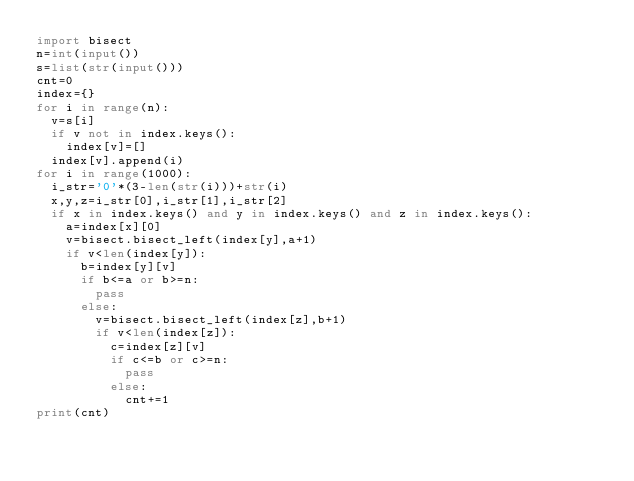Convert code to text. <code><loc_0><loc_0><loc_500><loc_500><_Python_>import bisect
n=int(input())
s=list(str(input()))
cnt=0
index={}
for i in range(n):
  v=s[i]
  if v not in index.keys():
    index[v]=[]
  index[v].append(i)
for i in range(1000):
  i_str='0'*(3-len(str(i)))+str(i)
  x,y,z=i_str[0],i_str[1],i_str[2]
  if x in index.keys() and y in index.keys() and z in index.keys():
    a=index[x][0]
    v=bisect.bisect_left(index[y],a+1)
    if v<len(index[y]):
      b=index[y][v]
      if b<=a or b>=n:
        pass
      else:
        v=bisect.bisect_left(index[z],b+1)
        if v<len(index[z]):
          c=index[z][v]
          if c<=b or c>=n:
            pass
          else:
            cnt+=1
print(cnt)</code> 